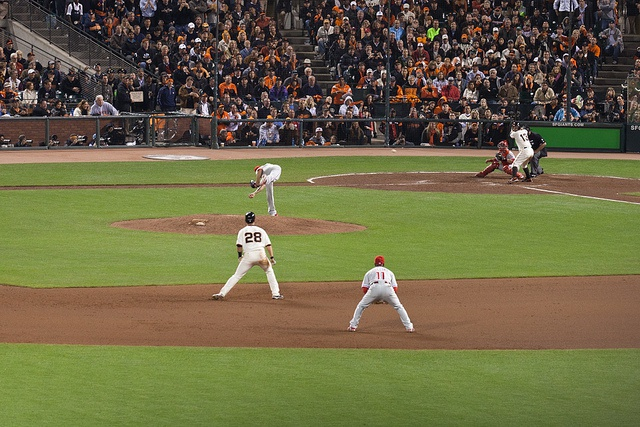Describe the objects in this image and their specific colors. I can see people in black, gray, and maroon tones, people in black, lightgray, olive, and gray tones, people in black, lightgray, darkgray, and gray tones, people in black, lightgray, darkgray, and gray tones, and people in black, lightgray, darkgray, and gray tones in this image. 